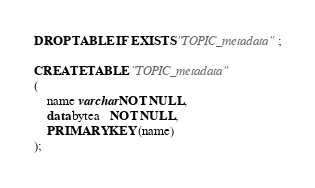Convert code to text. <code><loc_0><loc_0><loc_500><loc_500><_SQL_>DROP TABLE IF EXISTS "TOPIC_metadata";

CREATE TABLE "TOPIC_metadata"
(
    name varchar NOT NULL,
    data bytea   NOT NULL,
    PRIMARY KEY (name)
);
</code> 